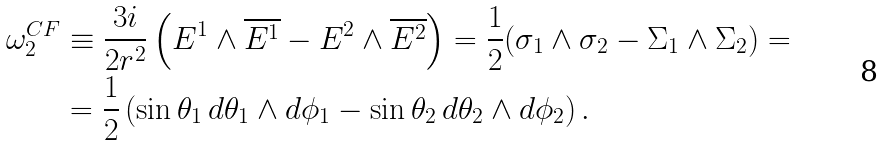<formula> <loc_0><loc_0><loc_500><loc_500>\omega _ { 2 } ^ { C F } & \equiv \frac { 3 i } { 2 r ^ { 2 } } \left ( E ^ { 1 } \wedge \overline { E ^ { 1 } } - E ^ { 2 } \wedge \overline { E ^ { 2 } } \right ) = \frac { 1 } { 2 } ( \sigma _ { 1 } \wedge \sigma _ { 2 } - \Sigma _ { 1 } \wedge \Sigma _ { 2 } ) = \\ & = \frac { 1 } { 2 } \left ( \sin \theta _ { 1 } \, d \theta _ { 1 } \wedge d \phi _ { 1 } - \sin \theta _ { 2 } \, d \theta _ { 2 } \wedge d \phi _ { 2 } \right ) .</formula> 